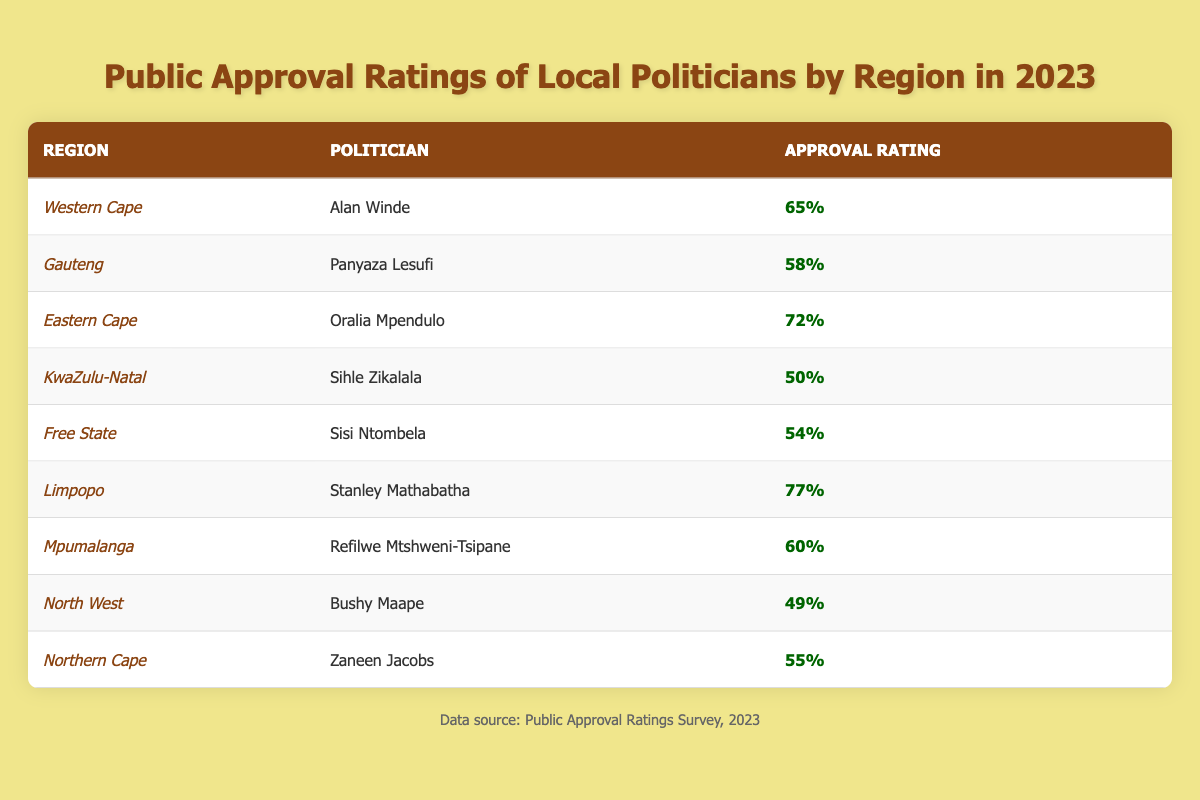What is the approval rating of Alan Winde in the Western Cape? According to the table, Alan Winde's approval rating in the Western Cape is 65%.
Answer: 65% Which politician has the highest approval rating in 2023? By checking the approval ratings listed in the table, Stanley Mathabatha from Limpopo has the highest rating at 77%.
Answer: Stanley Mathabatha Is the approval rating of Sihle Zikalala higher than 50%? The table indicates that Sihle Zikalala has an approval rating of 50%, so it is not higher than 50%.
Answer: No What is the average approval rating of politicians from the Eastern Cape and KwaZulu-Natal? The approval ratings for Oralia Mpendulo (Eastern Cape) is 72% and Sihle Zikalala (KwaZulu-Natal) is 50%. To find the average: (72 + 50) / 2 = 122 / 2 = 61%.
Answer: 61% Which regions have approval ratings below 55%? The table shows that KwaZulu-Natal (50%) and North West (49%) have approval ratings below 55%.
Answer: KwaZulu-Natal and North West What is the difference in approval ratings between Limpopo and Free State politicians? The approval rating of Stanley Mathabatha from Limpopo is 77%, while Sisi Ntombela from Free State has 54%. The difference is calculated as 77 - 54 = 23%.
Answer: 23% Is Panyaza Lesufi's approval rating above the average of all ratings? The average of all politicians' approval ratings is calculated as (65 + 58 + 72 + 50 + 54 + 77 + 60 + 49 + 55) / 9 = 58.33%. Panyaza Lesufi's rating of 58% is not above this average.
Answer: No What percent of politicians have approval ratings above 60%? Out of the 9 politicians, 5 (Alan Winde, Oralia Mpendulo, Stanley Mathabatha, Refilwe Mtshweni-Tsipane) have ratings above 60%. To find the percentage: (5/9)*100 = 55.56%, so approximately 56% of politicians have above 60%.
Answer: 56% 